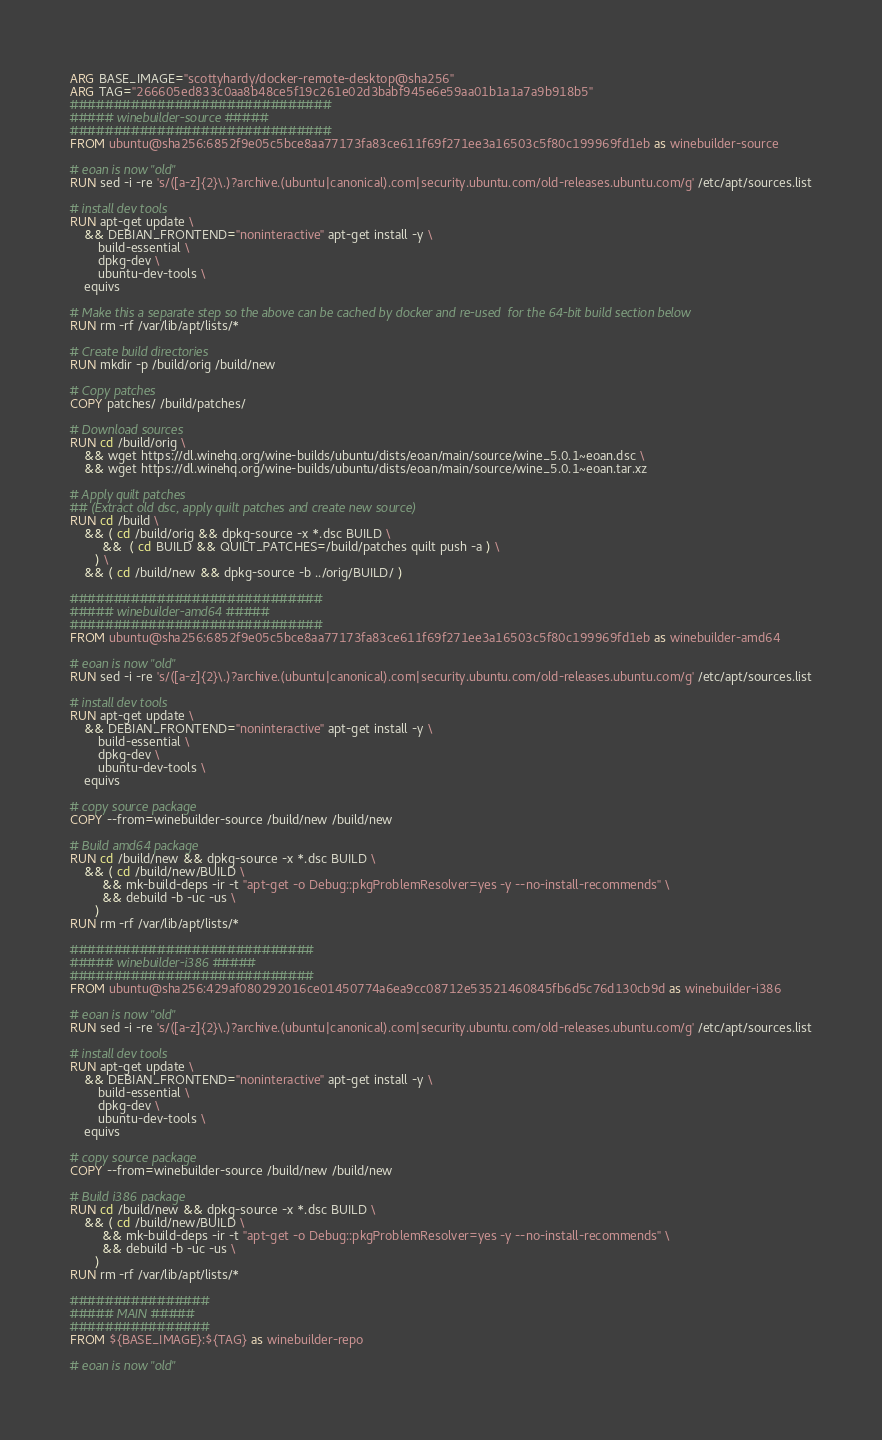Convert code to text. <code><loc_0><loc_0><loc_500><loc_500><_Dockerfile_>ARG BASE_IMAGE="scottyhardy/docker-remote-desktop@sha256"
ARG TAG="266605ed833c0aa8b48ce5f19c261e02d3babf945e6e59aa01b1a1a7a9b918b5"
##############################
##### winebuilder-source #####
##############################
FROM ubuntu@sha256:6852f9e05c5bce8aa77173fa83ce611f69f271ee3a16503c5f80c199969fd1eb as winebuilder-source

# eoan is now "old"
RUN sed -i -re 's/([a-z]{2}\.)?archive.(ubuntu|canonical).com|security.ubuntu.com/old-releases.ubuntu.com/g' /etc/apt/sources.list

# install dev tools
RUN apt-get update \
    && DEBIAN_FRONTEND="noninteractive" apt-get install -y \
        build-essential \
        dpkg-dev \
        ubuntu-dev-tools \
	equivs

# Make this a separate step so the above can be cached by docker and re-used  for the 64-bit build section below
RUN rm -rf /var/lib/apt/lists/*

# Create build directories
RUN mkdir -p /build/orig /build/new 

# Copy patches
COPY patches/ /build/patches/

# Download sources
RUN cd /build/orig \
    && wget https://dl.winehq.org/wine-builds/ubuntu/dists/eoan/main/source/wine_5.0.1~eoan.dsc \
    && wget https://dl.winehq.org/wine-builds/ubuntu/dists/eoan/main/source/wine_5.0.1~eoan.tar.xz

# Apply quilt patches 
## (Extract old dsc, apply quilt patches and create new source)
RUN cd /build \
    && ( cd /build/orig && dpkg-source -x *.dsc BUILD \
         &&  ( cd BUILD && QUILT_PATCHES=/build/patches quilt push -a ) \
       ) \
    && ( cd /build/new && dpkg-source -b ../orig/BUILD/ )

#############################
##### winebuilder-amd64 #####
#############################
FROM ubuntu@sha256:6852f9e05c5bce8aa77173fa83ce611f69f271ee3a16503c5f80c199969fd1eb as winebuilder-amd64

# eoan is now "old"
RUN sed -i -re 's/([a-z]{2}\.)?archive.(ubuntu|canonical).com|security.ubuntu.com/old-releases.ubuntu.com/g' /etc/apt/sources.list

# install dev tools
RUN apt-get update \
    && DEBIAN_FRONTEND="noninteractive" apt-get install -y \
        build-essential \
        dpkg-dev \
        ubuntu-dev-tools \
	equivs

# copy source package
COPY --from=winebuilder-source /build/new /build/new

# Build amd64 package
RUN cd /build/new && dpkg-source -x *.dsc BUILD \
    && ( cd /build/new/BUILD \
         && mk-build-deps -ir -t "apt-get -o Debug::pkgProblemResolver=yes -y --no-install-recommends" \
         && debuild -b -uc -us \
       )
RUN rm -rf /var/lib/apt/lists/*

############################
##### winebuilder-i386 #####
############################
FROM ubuntu@sha256:429af080292016ce01450774a6ea9cc08712e53521460845fb6d5c76d130cb9d as winebuilder-i386

# eoan is now "old"
RUN sed -i -re 's/([a-z]{2}\.)?archive.(ubuntu|canonical).com|security.ubuntu.com/old-releases.ubuntu.com/g' /etc/apt/sources.list

# install dev tools
RUN apt-get update \
    && DEBIAN_FRONTEND="noninteractive" apt-get install -y \
        build-essential \
        dpkg-dev \
        ubuntu-dev-tools \
	equivs 

# copy source package
COPY --from=winebuilder-source /build/new /build/new

# Build i386 package
RUN cd /build/new && dpkg-source -x *.dsc BUILD \
    && ( cd /build/new/BUILD \
         && mk-build-deps -ir -t "apt-get -o Debug::pkgProblemResolver=yes -y --no-install-recommends" \
         && debuild -b -uc -us \
       )
RUN rm -rf /var/lib/apt/lists/*

################
##### MAIN #####
################
FROM ${BASE_IMAGE}:${TAG} as winebuilder-repo

# eoan is now "old"</code> 